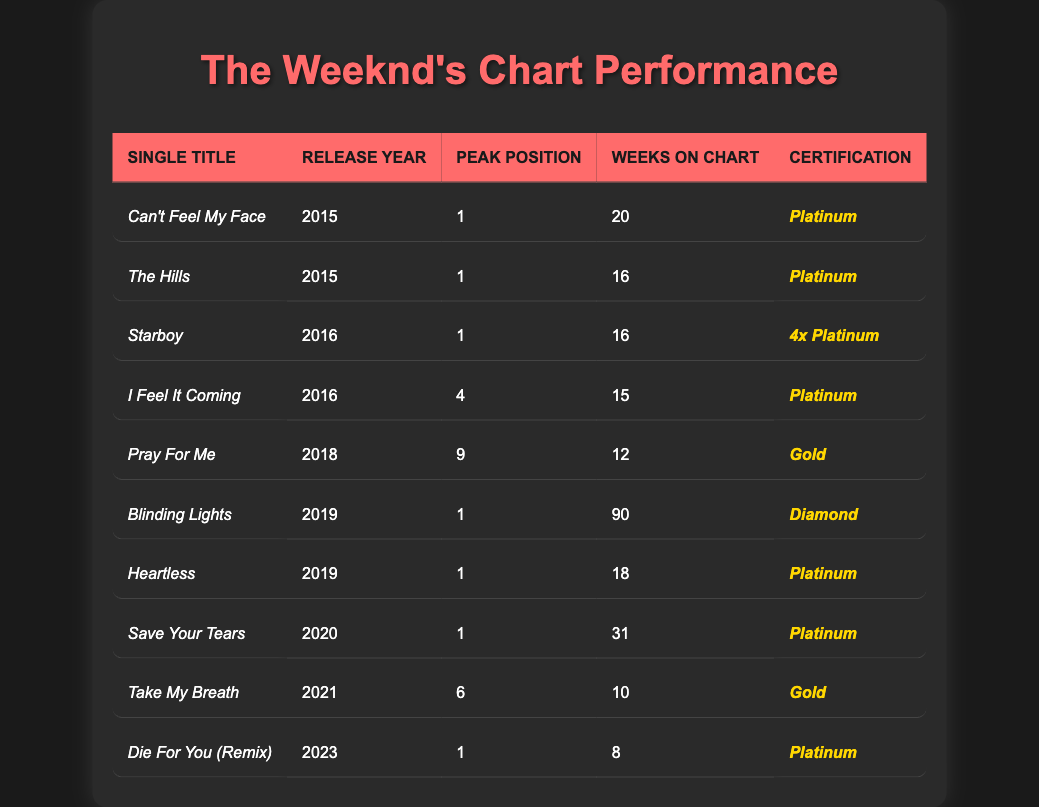What is the peak position of "Blinding Lights"? The peak position is listed in the table under the "Peak Position" column corresponding to "Blinding Lights," which is 1.
Answer: 1 How many weeks did "Save Your Tears" stay on the chart? The "Weeks on Chart" for "Save Your Tears" can be found in the corresponding row, which indicates it stayed for 31 weeks.
Answer: 31 Which single achieved the highest certification? "Blinding Lights" achieved a "Diamond" certification, which is the highest listed in the certification column of the table.
Answer: Diamond In which year did "Heartless" get released? The release year can be found in the table next to "Heartless," which indicates it was released in 2019.
Answer: 2019 What is the average peak position of singles released in 2016? The peak positions for 2016 are 1 (Starboy) and 4 (I Feel It Coming). The average is calculated as (1 + 4) / 2 = 2.5.
Answer: 2.5 Which single had the longest chart run? "Blinding Lights" had the longest run on the chart, with 90 weeks, as indicated in its corresponding row in the table.
Answer: Blinding Lights Did "Take My Breath" reach the top 5 in any chart? The peak position for "Take My Breath" is 6, so it did not reach the top 5 as per the information in the table.
Answer: No Which singles released in 2015 also achieved a Platinum certification? The singles "Can't Feel My Face" and "The Hills," both released in 2015, received Platinum certification as stated in their respective rows.
Answer: Can't Feel My Face, The Hills How many singles reached the peak position of 1? The singles listed with a peak position of 1 are "Can't Feel My Face," "The Hills," "Starboy," "Blinding Lights," "Heartless," "Save Your Tears," and "Die For You (Remix)"—a total of 7 singles.
Answer: 7 What is the total number of weeks on the chart for singles released in 2019? The singles released in 2019 are "Blinding Lights" (90 weeks) and "Heartless" (18 weeks). Adding those together gives 90 + 18 = 108 weeks.
Answer: 108 